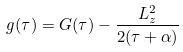Convert formula to latex. <formula><loc_0><loc_0><loc_500><loc_500>g ( \tau ) = G ( \tau ) - \frac { L _ { z } ^ { 2 } } { 2 ( \tau + \alpha ) }</formula> 